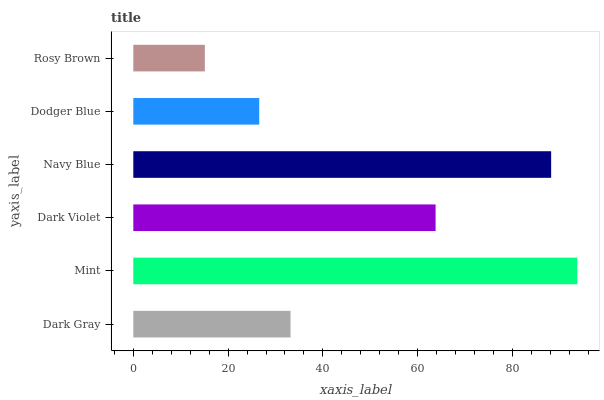Is Rosy Brown the minimum?
Answer yes or no. Yes. Is Mint the maximum?
Answer yes or no. Yes. Is Dark Violet the minimum?
Answer yes or no. No. Is Dark Violet the maximum?
Answer yes or no. No. Is Mint greater than Dark Violet?
Answer yes or no. Yes. Is Dark Violet less than Mint?
Answer yes or no. Yes. Is Dark Violet greater than Mint?
Answer yes or no. No. Is Mint less than Dark Violet?
Answer yes or no. No. Is Dark Violet the high median?
Answer yes or no. Yes. Is Dark Gray the low median?
Answer yes or no. Yes. Is Navy Blue the high median?
Answer yes or no. No. Is Mint the low median?
Answer yes or no. No. 